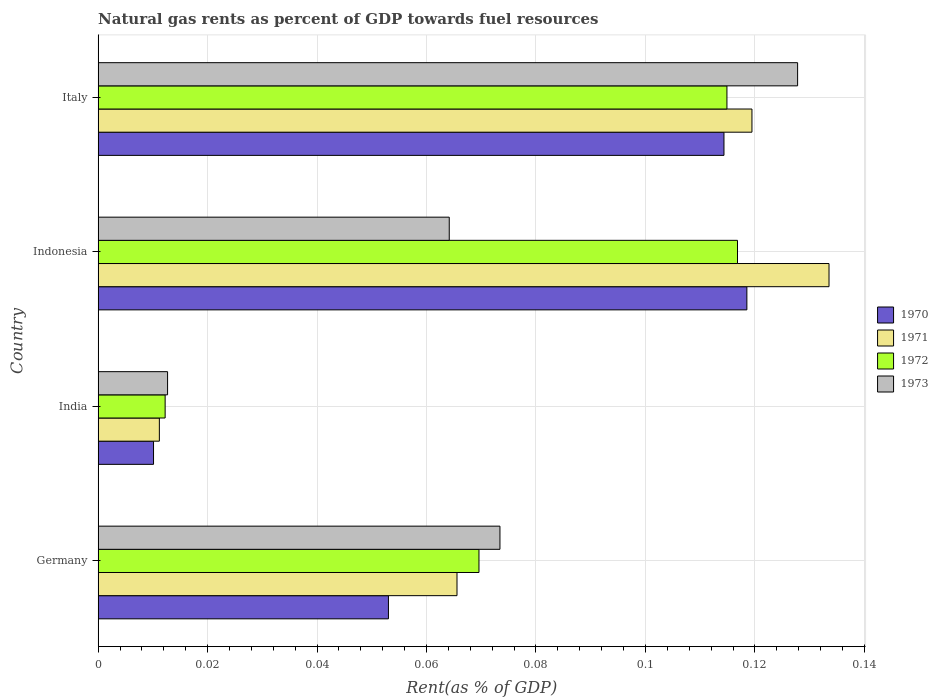How many different coloured bars are there?
Make the answer very short. 4. Are the number of bars per tick equal to the number of legend labels?
Your answer should be very brief. Yes. Are the number of bars on each tick of the Y-axis equal?
Your answer should be compact. Yes. How many bars are there on the 3rd tick from the top?
Offer a very short reply. 4. What is the label of the 4th group of bars from the top?
Provide a short and direct response. Germany. What is the matural gas rent in 1973 in Italy?
Make the answer very short. 0.13. Across all countries, what is the maximum matural gas rent in 1971?
Give a very brief answer. 0.13. Across all countries, what is the minimum matural gas rent in 1972?
Your answer should be very brief. 0.01. What is the total matural gas rent in 1973 in the graph?
Provide a succinct answer. 0.28. What is the difference between the matural gas rent in 1973 in Germany and that in Italy?
Keep it short and to the point. -0.05. What is the difference between the matural gas rent in 1973 in India and the matural gas rent in 1971 in Italy?
Make the answer very short. -0.11. What is the average matural gas rent in 1970 per country?
Offer a very short reply. 0.07. What is the difference between the matural gas rent in 1970 and matural gas rent in 1973 in Indonesia?
Provide a short and direct response. 0.05. What is the ratio of the matural gas rent in 1971 in Germany to that in Indonesia?
Your answer should be compact. 0.49. Is the difference between the matural gas rent in 1970 in India and Indonesia greater than the difference between the matural gas rent in 1973 in India and Indonesia?
Offer a terse response. No. What is the difference between the highest and the second highest matural gas rent in 1973?
Ensure brevity in your answer.  0.05. What is the difference between the highest and the lowest matural gas rent in 1972?
Keep it short and to the point. 0.1. Is it the case that in every country, the sum of the matural gas rent in 1971 and matural gas rent in 1970 is greater than the sum of matural gas rent in 1973 and matural gas rent in 1972?
Provide a succinct answer. No. What does the 1st bar from the top in Germany represents?
Ensure brevity in your answer.  1973. How many bars are there?
Your response must be concise. 16. Are all the bars in the graph horizontal?
Your response must be concise. Yes. Are the values on the major ticks of X-axis written in scientific E-notation?
Keep it short and to the point. No. What is the title of the graph?
Ensure brevity in your answer.  Natural gas rents as percent of GDP towards fuel resources. What is the label or title of the X-axis?
Offer a very short reply. Rent(as % of GDP). What is the label or title of the Y-axis?
Offer a very short reply. Country. What is the Rent(as % of GDP) of 1970 in Germany?
Ensure brevity in your answer.  0.05. What is the Rent(as % of GDP) in 1971 in Germany?
Give a very brief answer. 0.07. What is the Rent(as % of GDP) of 1972 in Germany?
Keep it short and to the point. 0.07. What is the Rent(as % of GDP) of 1973 in Germany?
Provide a short and direct response. 0.07. What is the Rent(as % of GDP) of 1970 in India?
Make the answer very short. 0.01. What is the Rent(as % of GDP) of 1971 in India?
Offer a terse response. 0.01. What is the Rent(as % of GDP) in 1972 in India?
Make the answer very short. 0.01. What is the Rent(as % of GDP) of 1973 in India?
Provide a succinct answer. 0.01. What is the Rent(as % of GDP) of 1970 in Indonesia?
Your answer should be very brief. 0.12. What is the Rent(as % of GDP) of 1971 in Indonesia?
Offer a terse response. 0.13. What is the Rent(as % of GDP) of 1972 in Indonesia?
Keep it short and to the point. 0.12. What is the Rent(as % of GDP) of 1973 in Indonesia?
Provide a succinct answer. 0.06. What is the Rent(as % of GDP) in 1970 in Italy?
Give a very brief answer. 0.11. What is the Rent(as % of GDP) in 1971 in Italy?
Offer a very short reply. 0.12. What is the Rent(as % of GDP) in 1972 in Italy?
Your answer should be very brief. 0.11. What is the Rent(as % of GDP) in 1973 in Italy?
Your response must be concise. 0.13. Across all countries, what is the maximum Rent(as % of GDP) in 1970?
Keep it short and to the point. 0.12. Across all countries, what is the maximum Rent(as % of GDP) in 1971?
Ensure brevity in your answer.  0.13. Across all countries, what is the maximum Rent(as % of GDP) of 1972?
Your answer should be compact. 0.12. Across all countries, what is the maximum Rent(as % of GDP) of 1973?
Make the answer very short. 0.13. Across all countries, what is the minimum Rent(as % of GDP) in 1970?
Keep it short and to the point. 0.01. Across all countries, what is the minimum Rent(as % of GDP) in 1971?
Offer a terse response. 0.01. Across all countries, what is the minimum Rent(as % of GDP) in 1972?
Give a very brief answer. 0.01. Across all countries, what is the minimum Rent(as % of GDP) of 1973?
Keep it short and to the point. 0.01. What is the total Rent(as % of GDP) of 1970 in the graph?
Offer a very short reply. 0.3. What is the total Rent(as % of GDP) in 1971 in the graph?
Give a very brief answer. 0.33. What is the total Rent(as % of GDP) in 1972 in the graph?
Your response must be concise. 0.31. What is the total Rent(as % of GDP) in 1973 in the graph?
Your answer should be very brief. 0.28. What is the difference between the Rent(as % of GDP) in 1970 in Germany and that in India?
Give a very brief answer. 0.04. What is the difference between the Rent(as % of GDP) of 1971 in Germany and that in India?
Make the answer very short. 0.05. What is the difference between the Rent(as % of GDP) in 1972 in Germany and that in India?
Make the answer very short. 0.06. What is the difference between the Rent(as % of GDP) of 1973 in Germany and that in India?
Offer a very short reply. 0.06. What is the difference between the Rent(as % of GDP) of 1970 in Germany and that in Indonesia?
Your answer should be very brief. -0.07. What is the difference between the Rent(as % of GDP) of 1971 in Germany and that in Indonesia?
Your answer should be very brief. -0.07. What is the difference between the Rent(as % of GDP) of 1972 in Germany and that in Indonesia?
Offer a terse response. -0.05. What is the difference between the Rent(as % of GDP) of 1973 in Germany and that in Indonesia?
Offer a very short reply. 0.01. What is the difference between the Rent(as % of GDP) in 1970 in Germany and that in Italy?
Provide a succinct answer. -0.06. What is the difference between the Rent(as % of GDP) in 1971 in Germany and that in Italy?
Your response must be concise. -0.05. What is the difference between the Rent(as % of GDP) in 1972 in Germany and that in Italy?
Keep it short and to the point. -0.05. What is the difference between the Rent(as % of GDP) of 1973 in Germany and that in Italy?
Keep it short and to the point. -0.05. What is the difference between the Rent(as % of GDP) of 1970 in India and that in Indonesia?
Provide a succinct answer. -0.11. What is the difference between the Rent(as % of GDP) of 1971 in India and that in Indonesia?
Keep it short and to the point. -0.12. What is the difference between the Rent(as % of GDP) of 1972 in India and that in Indonesia?
Provide a succinct answer. -0.1. What is the difference between the Rent(as % of GDP) in 1973 in India and that in Indonesia?
Keep it short and to the point. -0.05. What is the difference between the Rent(as % of GDP) of 1970 in India and that in Italy?
Offer a very short reply. -0.1. What is the difference between the Rent(as % of GDP) in 1971 in India and that in Italy?
Your answer should be very brief. -0.11. What is the difference between the Rent(as % of GDP) in 1972 in India and that in Italy?
Provide a succinct answer. -0.1. What is the difference between the Rent(as % of GDP) of 1973 in India and that in Italy?
Make the answer very short. -0.12. What is the difference between the Rent(as % of GDP) of 1970 in Indonesia and that in Italy?
Offer a terse response. 0. What is the difference between the Rent(as % of GDP) in 1971 in Indonesia and that in Italy?
Make the answer very short. 0.01. What is the difference between the Rent(as % of GDP) in 1972 in Indonesia and that in Italy?
Give a very brief answer. 0. What is the difference between the Rent(as % of GDP) of 1973 in Indonesia and that in Italy?
Ensure brevity in your answer.  -0.06. What is the difference between the Rent(as % of GDP) in 1970 in Germany and the Rent(as % of GDP) in 1971 in India?
Make the answer very short. 0.04. What is the difference between the Rent(as % of GDP) of 1970 in Germany and the Rent(as % of GDP) of 1972 in India?
Provide a succinct answer. 0.04. What is the difference between the Rent(as % of GDP) in 1970 in Germany and the Rent(as % of GDP) in 1973 in India?
Give a very brief answer. 0.04. What is the difference between the Rent(as % of GDP) of 1971 in Germany and the Rent(as % of GDP) of 1972 in India?
Your response must be concise. 0.05. What is the difference between the Rent(as % of GDP) of 1971 in Germany and the Rent(as % of GDP) of 1973 in India?
Offer a very short reply. 0.05. What is the difference between the Rent(as % of GDP) of 1972 in Germany and the Rent(as % of GDP) of 1973 in India?
Offer a very short reply. 0.06. What is the difference between the Rent(as % of GDP) in 1970 in Germany and the Rent(as % of GDP) in 1971 in Indonesia?
Make the answer very short. -0.08. What is the difference between the Rent(as % of GDP) in 1970 in Germany and the Rent(as % of GDP) in 1972 in Indonesia?
Offer a terse response. -0.06. What is the difference between the Rent(as % of GDP) in 1970 in Germany and the Rent(as % of GDP) in 1973 in Indonesia?
Keep it short and to the point. -0.01. What is the difference between the Rent(as % of GDP) of 1971 in Germany and the Rent(as % of GDP) of 1972 in Indonesia?
Ensure brevity in your answer.  -0.05. What is the difference between the Rent(as % of GDP) in 1971 in Germany and the Rent(as % of GDP) in 1973 in Indonesia?
Your answer should be compact. 0. What is the difference between the Rent(as % of GDP) of 1972 in Germany and the Rent(as % of GDP) of 1973 in Indonesia?
Your answer should be compact. 0.01. What is the difference between the Rent(as % of GDP) of 1970 in Germany and the Rent(as % of GDP) of 1971 in Italy?
Keep it short and to the point. -0.07. What is the difference between the Rent(as % of GDP) of 1970 in Germany and the Rent(as % of GDP) of 1972 in Italy?
Make the answer very short. -0.06. What is the difference between the Rent(as % of GDP) in 1970 in Germany and the Rent(as % of GDP) in 1973 in Italy?
Provide a succinct answer. -0.07. What is the difference between the Rent(as % of GDP) in 1971 in Germany and the Rent(as % of GDP) in 1972 in Italy?
Make the answer very short. -0.05. What is the difference between the Rent(as % of GDP) of 1971 in Germany and the Rent(as % of GDP) of 1973 in Italy?
Your answer should be very brief. -0.06. What is the difference between the Rent(as % of GDP) of 1972 in Germany and the Rent(as % of GDP) of 1973 in Italy?
Give a very brief answer. -0.06. What is the difference between the Rent(as % of GDP) in 1970 in India and the Rent(as % of GDP) in 1971 in Indonesia?
Provide a short and direct response. -0.12. What is the difference between the Rent(as % of GDP) of 1970 in India and the Rent(as % of GDP) of 1972 in Indonesia?
Your answer should be compact. -0.11. What is the difference between the Rent(as % of GDP) of 1970 in India and the Rent(as % of GDP) of 1973 in Indonesia?
Your answer should be compact. -0.05. What is the difference between the Rent(as % of GDP) of 1971 in India and the Rent(as % of GDP) of 1972 in Indonesia?
Your response must be concise. -0.11. What is the difference between the Rent(as % of GDP) in 1971 in India and the Rent(as % of GDP) in 1973 in Indonesia?
Ensure brevity in your answer.  -0.05. What is the difference between the Rent(as % of GDP) of 1972 in India and the Rent(as % of GDP) of 1973 in Indonesia?
Provide a short and direct response. -0.05. What is the difference between the Rent(as % of GDP) in 1970 in India and the Rent(as % of GDP) in 1971 in Italy?
Offer a terse response. -0.11. What is the difference between the Rent(as % of GDP) in 1970 in India and the Rent(as % of GDP) in 1972 in Italy?
Give a very brief answer. -0.1. What is the difference between the Rent(as % of GDP) in 1970 in India and the Rent(as % of GDP) in 1973 in Italy?
Keep it short and to the point. -0.12. What is the difference between the Rent(as % of GDP) in 1971 in India and the Rent(as % of GDP) in 1972 in Italy?
Give a very brief answer. -0.1. What is the difference between the Rent(as % of GDP) in 1971 in India and the Rent(as % of GDP) in 1973 in Italy?
Offer a terse response. -0.12. What is the difference between the Rent(as % of GDP) in 1972 in India and the Rent(as % of GDP) in 1973 in Italy?
Ensure brevity in your answer.  -0.12. What is the difference between the Rent(as % of GDP) of 1970 in Indonesia and the Rent(as % of GDP) of 1971 in Italy?
Offer a very short reply. -0. What is the difference between the Rent(as % of GDP) in 1970 in Indonesia and the Rent(as % of GDP) in 1972 in Italy?
Keep it short and to the point. 0. What is the difference between the Rent(as % of GDP) in 1970 in Indonesia and the Rent(as % of GDP) in 1973 in Italy?
Your response must be concise. -0.01. What is the difference between the Rent(as % of GDP) in 1971 in Indonesia and the Rent(as % of GDP) in 1972 in Italy?
Provide a short and direct response. 0.02. What is the difference between the Rent(as % of GDP) in 1971 in Indonesia and the Rent(as % of GDP) in 1973 in Italy?
Ensure brevity in your answer.  0.01. What is the difference between the Rent(as % of GDP) of 1972 in Indonesia and the Rent(as % of GDP) of 1973 in Italy?
Your answer should be very brief. -0.01. What is the average Rent(as % of GDP) in 1970 per country?
Offer a very short reply. 0.07. What is the average Rent(as % of GDP) of 1971 per country?
Give a very brief answer. 0.08. What is the average Rent(as % of GDP) of 1972 per country?
Provide a succinct answer. 0.08. What is the average Rent(as % of GDP) in 1973 per country?
Your response must be concise. 0.07. What is the difference between the Rent(as % of GDP) in 1970 and Rent(as % of GDP) in 1971 in Germany?
Your response must be concise. -0.01. What is the difference between the Rent(as % of GDP) in 1970 and Rent(as % of GDP) in 1972 in Germany?
Keep it short and to the point. -0.02. What is the difference between the Rent(as % of GDP) of 1970 and Rent(as % of GDP) of 1973 in Germany?
Ensure brevity in your answer.  -0.02. What is the difference between the Rent(as % of GDP) in 1971 and Rent(as % of GDP) in 1972 in Germany?
Provide a succinct answer. -0. What is the difference between the Rent(as % of GDP) in 1971 and Rent(as % of GDP) in 1973 in Germany?
Offer a terse response. -0.01. What is the difference between the Rent(as % of GDP) of 1972 and Rent(as % of GDP) of 1973 in Germany?
Provide a short and direct response. -0. What is the difference between the Rent(as % of GDP) of 1970 and Rent(as % of GDP) of 1971 in India?
Ensure brevity in your answer.  -0. What is the difference between the Rent(as % of GDP) of 1970 and Rent(as % of GDP) of 1972 in India?
Offer a terse response. -0. What is the difference between the Rent(as % of GDP) in 1970 and Rent(as % of GDP) in 1973 in India?
Offer a terse response. -0. What is the difference between the Rent(as % of GDP) of 1971 and Rent(as % of GDP) of 1972 in India?
Ensure brevity in your answer.  -0. What is the difference between the Rent(as % of GDP) of 1971 and Rent(as % of GDP) of 1973 in India?
Offer a terse response. -0. What is the difference between the Rent(as % of GDP) in 1972 and Rent(as % of GDP) in 1973 in India?
Make the answer very short. -0. What is the difference between the Rent(as % of GDP) in 1970 and Rent(as % of GDP) in 1971 in Indonesia?
Provide a succinct answer. -0.01. What is the difference between the Rent(as % of GDP) in 1970 and Rent(as % of GDP) in 1972 in Indonesia?
Ensure brevity in your answer.  0. What is the difference between the Rent(as % of GDP) of 1970 and Rent(as % of GDP) of 1973 in Indonesia?
Your response must be concise. 0.05. What is the difference between the Rent(as % of GDP) of 1971 and Rent(as % of GDP) of 1972 in Indonesia?
Your response must be concise. 0.02. What is the difference between the Rent(as % of GDP) in 1971 and Rent(as % of GDP) in 1973 in Indonesia?
Provide a short and direct response. 0.07. What is the difference between the Rent(as % of GDP) of 1972 and Rent(as % of GDP) of 1973 in Indonesia?
Make the answer very short. 0.05. What is the difference between the Rent(as % of GDP) of 1970 and Rent(as % of GDP) of 1971 in Italy?
Your answer should be very brief. -0.01. What is the difference between the Rent(as % of GDP) of 1970 and Rent(as % of GDP) of 1972 in Italy?
Provide a short and direct response. -0. What is the difference between the Rent(as % of GDP) in 1970 and Rent(as % of GDP) in 1973 in Italy?
Give a very brief answer. -0.01. What is the difference between the Rent(as % of GDP) in 1971 and Rent(as % of GDP) in 1972 in Italy?
Ensure brevity in your answer.  0. What is the difference between the Rent(as % of GDP) in 1971 and Rent(as % of GDP) in 1973 in Italy?
Ensure brevity in your answer.  -0.01. What is the difference between the Rent(as % of GDP) in 1972 and Rent(as % of GDP) in 1973 in Italy?
Offer a terse response. -0.01. What is the ratio of the Rent(as % of GDP) in 1970 in Germany to that in India?
Your answer should be very brief. 5.24. What is the ratio of the Rent(as % of GDP) in 1971 in Germany to that in India?
Give a very brief answer. 5.86. What is the ratio of the Rent(as % of GDP) of 1972 in Germany to that in India?
Your response must be concise. 5.68. What is the ratio of the Rent(as % of GDP) of 1973 in Germany to that in India?
Keep it short and to the point. 5.79. What is the ratio of the Rent(as % of GDP) of 1970 in Germany to that in Indonesia?
Provide a succinct answer. 0.45. What is the ratio of the Rent(as % of GDP) of 1971 in Germany to that in Indonesia?
Provide a succinct answer. 0.49. What is the ratio of the Rent(as % of GDP) of 1972 in Germany to that in Indonesia?
Your answer should be very brief. 0.6. What is the ratio of the Rent(as % of GDP) of 1973 in Germany to that in Indonesia?
Give a very brief answer. 1.14. What is the ratio of the Rent(as % of GDP) in 1970 in Germany to that in Italy?
Make the answer very short. 0.46. What is the ratio of the Rent(as % of GDP) in 1971 in Germany to that in Italy?
Provide a short and direct response. 0.55. What is the ratio of the Rent(as % of GDP) in 1972 in Germany to that in Italy?
Give a very brief answer. 0.61. What is the ratio of the Rent(as % of GDP) in 1973 in Germany to that in Italy?
Provide a short and direct response. 0.57. What is the ratio of the Rent(as % of GDP) in 1970 in India to that in Indonesia?
Make the answer very short. 0.09. What is the ratio of the Rent(as % of GDP) in 1971 in India to that in Indonesia?
Provide a succinct answer. 0.08. What is the ratio of the Rent(as % of GDP) in 1972 in India to that in Indonesia?
Ensure brevity in your answer.  0.1. What is the ratio of the Rent(as % of GDP) of 1973 in India to that in Indonesia?
Keep it short and to the point. 0.2. What is the ratio of the Rent(as % of GDP) of 1970 in India to that in Italy?
Your answer should be very brief. 0.09. What is the ratio of the Rent(as % of GDP) in 1971 in India to that in Italy?
Your response must be concise. 0.09. What is the ratio of the Rent(as % of GDP) in 1972 in India to that in Italy?
Ensure brevity in your answer.  0.11. What is the ratio of the Rent(as % of GDP) in 1973 in India to that in Italy?
Keep it short and to the point. 0.1. What is the ratio of the Rent(as % of GDP) of 1970 in Indonesia to that in Italy?
Provide a succinct answer. 1.04. What is the ratio of the Rent(as % of GDP) of 1971 in Indonesia to that in Italy?
Provide a succinct answer. 1.12. What is the ratio of the Rent(as % of GDP) in 1972 in Indonesia to that in Italy?
Your answer should be compact. 1.02. What is the ratio of the Rent(as % of GDP) of 1973 in Indonesia to that in Italy?
Offer a very short reply. 0.5. What is the difference between the highest and the second highest Rent(as % of GDP) in 1970?
Make the answer very short. 0. What is the difference between the highest and the second highest Rent(as % of GDP) in 1971?
Your answer should be very brief. 0.01. What is the difference between the highest and the second highest Rent(as % of GDP) in 1972?
Provide a succinct answer. 0. What is the difference between the highest and the second highest Rent(as % of GDP) in 1973?
Ensure brevity in your answer.  0.05. What is the difference between the highest and the lowest Rent(as % of GDP) in 1970?
Make the answer very short. 0.11. What is the difference between the highest and the lowest Rent(as % of GDP) of 1971?
Offer a terse response. 0.12. What is the difference between the highest and the lowest Rent(as % of GDP) of 1972?
Your response must be concise. 0.1. What is the difference between the highest and the lowest Rent(as % of GDP) of 1973?
Make the answer very short. 0.12. 